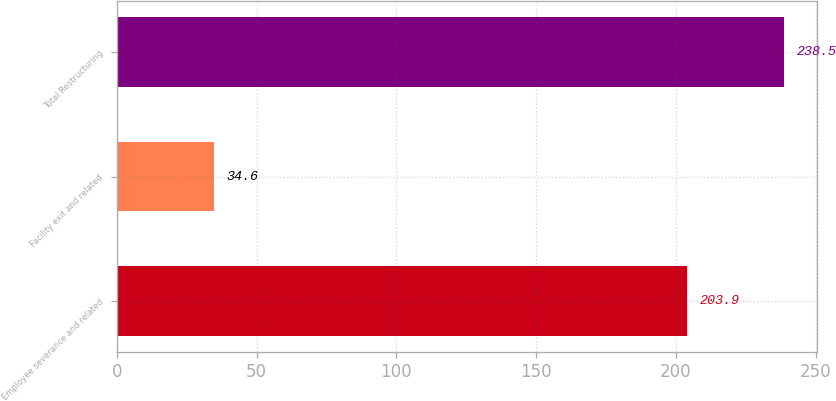<chart> <loc_0><loc_0><loc_500><loc_500><bar_chart><fcel>Employee severance and related<fcel>Facility exit and related<fcel>Total Restructuring<nl><fcel>203.9<fcel>34.6<fcel>238.5<nl></chart> 